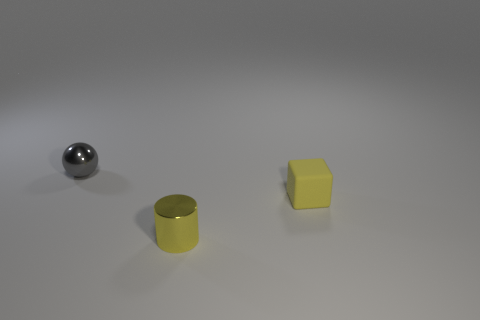What shape is the small yellow matte object? cube 